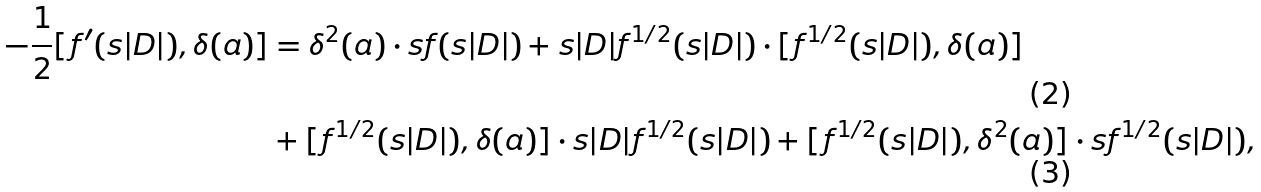<formula> <loc_0><loc_0><loc_500><loc_500>- \frac { 1 } { 2 } [ f ^ { \prime } ( s | D | ) , \delta ( a ) ] & = \delta ^ { 2 } ( a ) \cdot s f ( s | D | ) + s | D | f ^ { 1 / 2 } ( s | D | ) \cdot [ f ^ { 1 / 2 } ( s | D | ) , \delta ( a ) ] \\ & + [ f ^ { 1 / 2 } ( s | D | ) , \delta ( a ) ] \cdot s | D | f ^ { 1 / 2 } ( s | D | ) + [ f ^ { 1 / 2 } ( s | D | ) , \delta ^ { 2 } ( a ) ] \cdot s f ^ { 1 / 2 } ( s | D | ) ,</formula> 